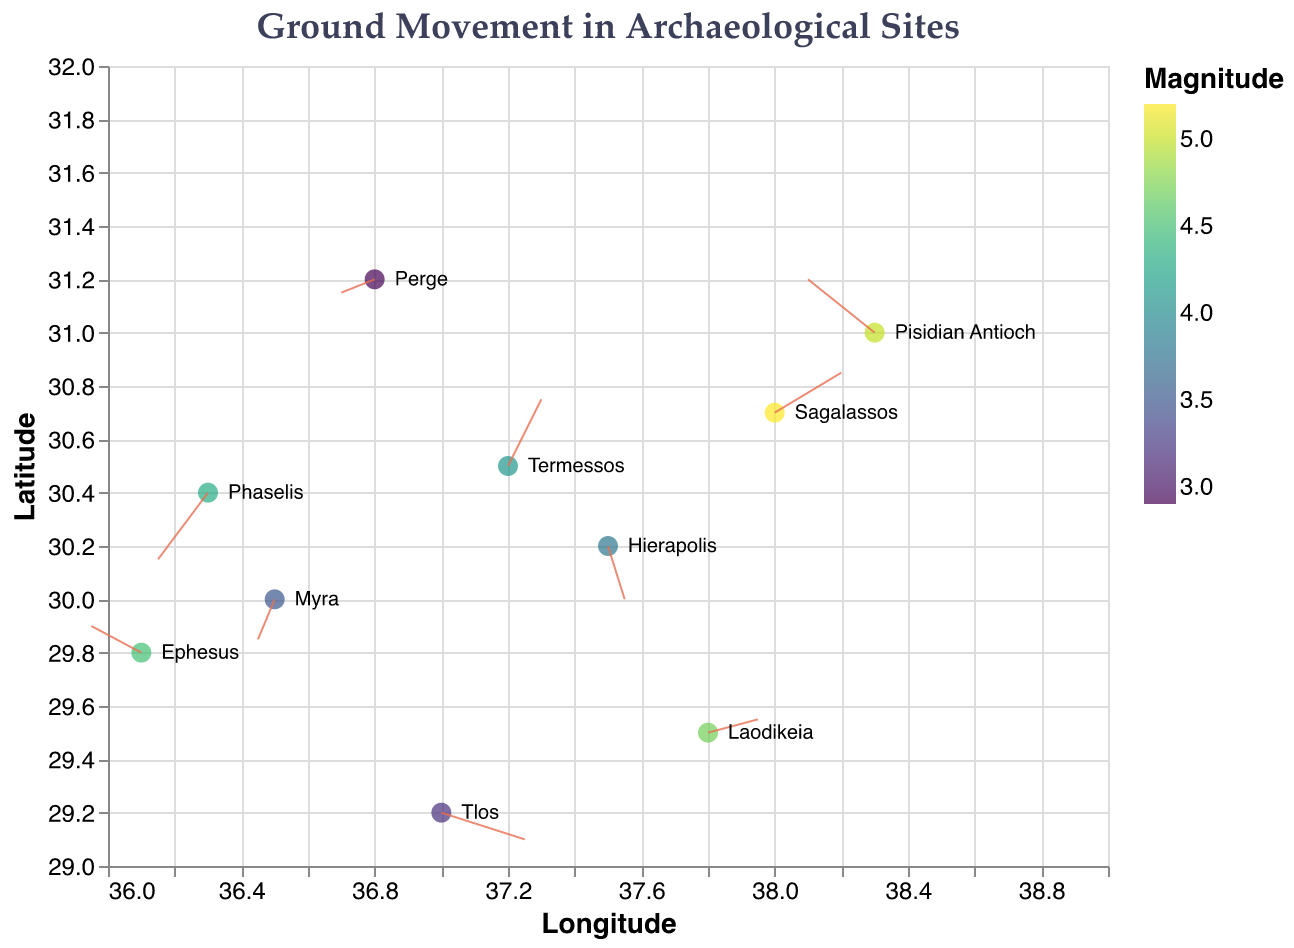What is the title of the figure? The title of the figure is shown at the top. It is "Ground Movement in Archaeological Sites".
Answer: Ground Movement in Archaeological Sites Which site has the highest magnitude value? To find the site with the highest magnitude, look at the color legend for magnitude and identify the data point with the darkest color. Then, refer to the tooltip labels.
Answer: Sagalassos At what latitude and longitude is Myra located? Locate Myra by finding its name label on the plot. Its latitude (y) and longitude (x) can be identified directly from its position on the axes.
Answer: Latitude: 30.0, Longitude: 36.5 Which site has the vector pointing in the direction where both x and y components are negative? Look for vectors (arrows) that point to the lower-left direction (both components of the vector are negative). Find the corresponding site from the labels or the tooltip information.
Answer: Perge What is the average magnitude of sites with vectors in the positive x and positive y direction? Identify the sites with positive x and y vectors by looking at the direction of the arrows. There are two such sites: Termessos and Sagalassos. Calculate their magnitude's average: (4.1 + 5.2) / 2 = 4.65.
Answer: 4.65 Compare the ground movement vectors of Laodikeia and Pisidian Antioch. Which one has a larger vector and what does that indicate? Check the vector lengths: Laodikeia has u=0.3, v=0.1 and Pisidian Antioch has u=-0.4, v=0.4. Calculate their magnitudes: Laodikeia's vector is sqrt(0.3^2 + 0.1^2) = 0.316, Pisidian Antioch's vector is sqrt(0.4^2 + 0.4^2) = 0.566. Pisidian Antioch has a larger vector, indicating more significant ground movement.
Answer: Pisidian Antioch, more ground movement What direction is the ground movement vector pointing at Ephesus, and what does that tell us? Find the vector at Ephesus (u=-0.3, v=0.2). Since x-component (u) is negative and y-component (v) is positive, it points to the upper-left direction. This indicates ground movement northwest.
Answer: Northwest Are there more sites with positive or negative x-component vectors? Count the vectors with positive x-component (Hierapolis, Sagalassos, Termessos, Laodikeia, Tlos) and negative x-component (Ephesus, Perge, Myra, Phaselis, Pisidian Antioch). Both groups have 5 sites each.
Answer: Equal What are the longitude and latitude scales on the axes in the plot? Longitude is on the x-axis ranging from 36 to 39. Latitude is on the y-axis ranging from 29 to 32. This can be seen on the plot's axis labels and scale indicators.
Answer: Longitude: 36-39, Latitude: 29-32 